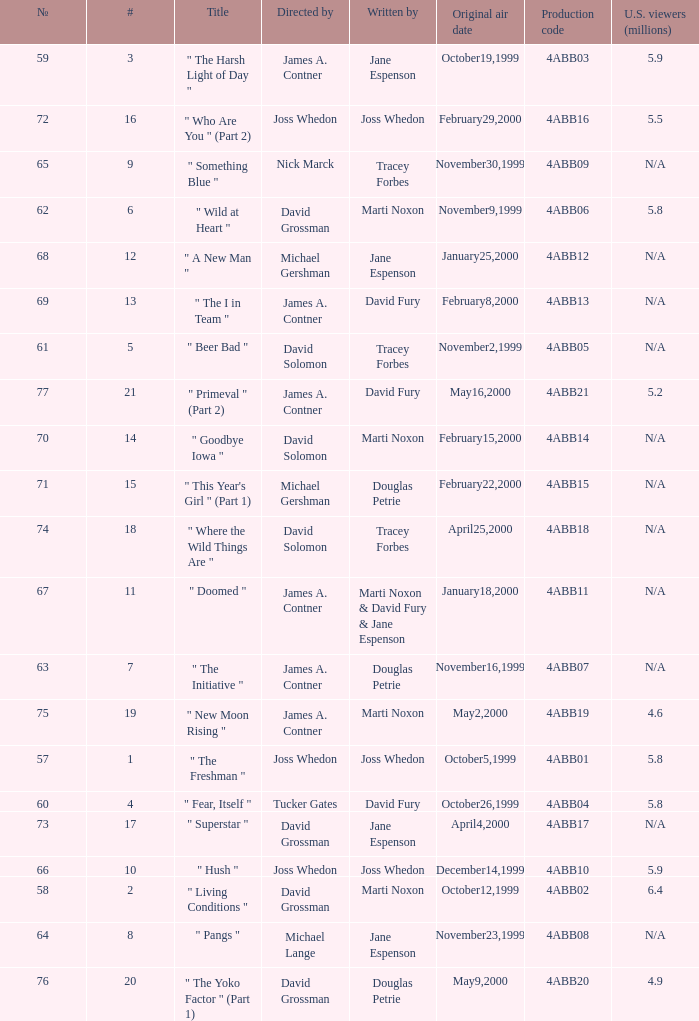Help me parse the entirety of this table. {'header': ['№', '#', 'Title', 'Directed by', 'Written by', 'Original air date', 'Production code', 'U.S. viewers (millions)'], 'rows': [['59', '3', '" The Harsh Light of Day "', 'James A. Contner', 'Jane Espenson', 'October19,1999', '4ABB03', '5.9'], ['72', '16', '" Who Are You " (Part 2)', 'Joss Whedon', 'Joss Whedon', 'February29,2000', '4ABB16', '5.5'], ['65', '9', '" Something Blue "', 'Nick Marck', 'Tracey Forbes', 'November30,1999', '4ABB09', 'N/A'], ['62', '6', '" Wild at Heart "', 'David Grossman', 'Marti Noxon', 'November9,1999', '4ABB06', '5.8'], ['68', '12', '" A New Man "', 'Michael Gershman', 'Jane Espenson', 'January25,2000', '4ABB12', 'N/A'], ['69', '13', '" The I in Team "', 'James A. Contner', 'David Fury', 'February8,2000', '4ABB13', 'N/A'], ['61', '5', '" Beer Bad "', 'David Solomon', 'Tracey Forbes', 'November2,1999', '4ABB05', 'N/A'], ['77', '21', '" Primeval " (Part 2)', 'James A. Contner', 'David Fury', 'May16,2000', '4ABB21', '5.2'], ['70', '14', '" Goodbye Iowa "', 'David Solomon', 'Marti Noxon', 'February15,2000', '4ABB14', 'N/A'], ['71', '15', '" This Year\'s Girl " (Part 1)', 'Michael Gershman', 'Douglas Petrie', 'February22,2000', '4ABB15', 'N/A'], ['74', '18', '" Where the Wild Things Are "', 'David Solomon', 'Tracey Forbes', 'April25,2000', '4ABB18', 'N/A'], ['67', '11', '" Doomed "', 'James A. Contner', 'Marti Noxon & David Fury & Jane Espenson', 'January18,2000', '4ABB11', 'N/A'], ['63', '7', '" The Initiative "', 'James A. Contner', 'Douglas Petrie', 'November16,1999', '4ABB07', 'N/A'], ['75', '19', '" New Moon Rising "', 'James A. Contner', 'Marti Noxon', 'May2,2000', '4ABB19', '4.6'], ['57', '1', '" The Freshman "', 'Joss Whedon', 'Joss Whedon', 'October5,1999', '4ABB01', '5.8'], ['60', '4', '" Fear, Itself "', 'Tucker Gates', 'David Fury', 'October26,1999', '4ABB04', '5.8'], ['73', '17', '" Superstar "', 'David Grossman', 'Jane Espenson', 'April4,2000', '4ABB17', 'N/A'], ['66', '10', '" Hush "', 'Joss Whedon', 'Joss Whedon', 'December14,1999', '4ABB10', '5.9'], ['58', '2', '" Living Conditions "', 'David Grossman', 'Marti Noxon', 'October12,1999', '4ABB02', '6.4'], ['64', '8', '" Pangs "', 'Michael Lange', 'Jane Espenson', 'November23,1999', '4ABB08', 'N/A'], ['76', '20', '" The Yoko Factor " (Part 1)', 'David Grossman', 'Douglas Petrie', 'May9,2000', '4ABB20', '4.9']]} What is the series No when the season 4 # is 18? 74.0. 